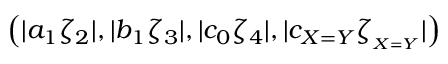<formula> <loc_0><loc_0><loc_500><loc_500>\left ( | a _ { 1 } \zeta _ { 2 } | , | b _ { 1 } \zeta _ { 3 } | , | c _ { 0 } \zeta _ { 4 } | , | c _ { X = Y } \zeta _ { _ { X = Y } } | \right )</formula> 